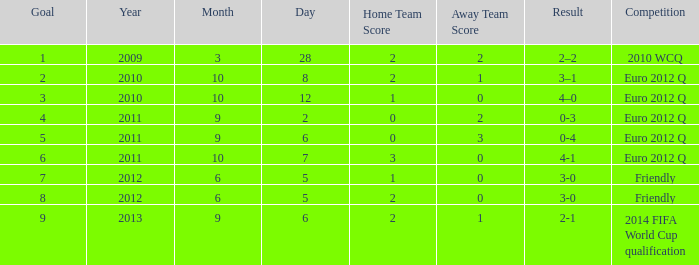What is the result when the score is 0-2? 0-3. 